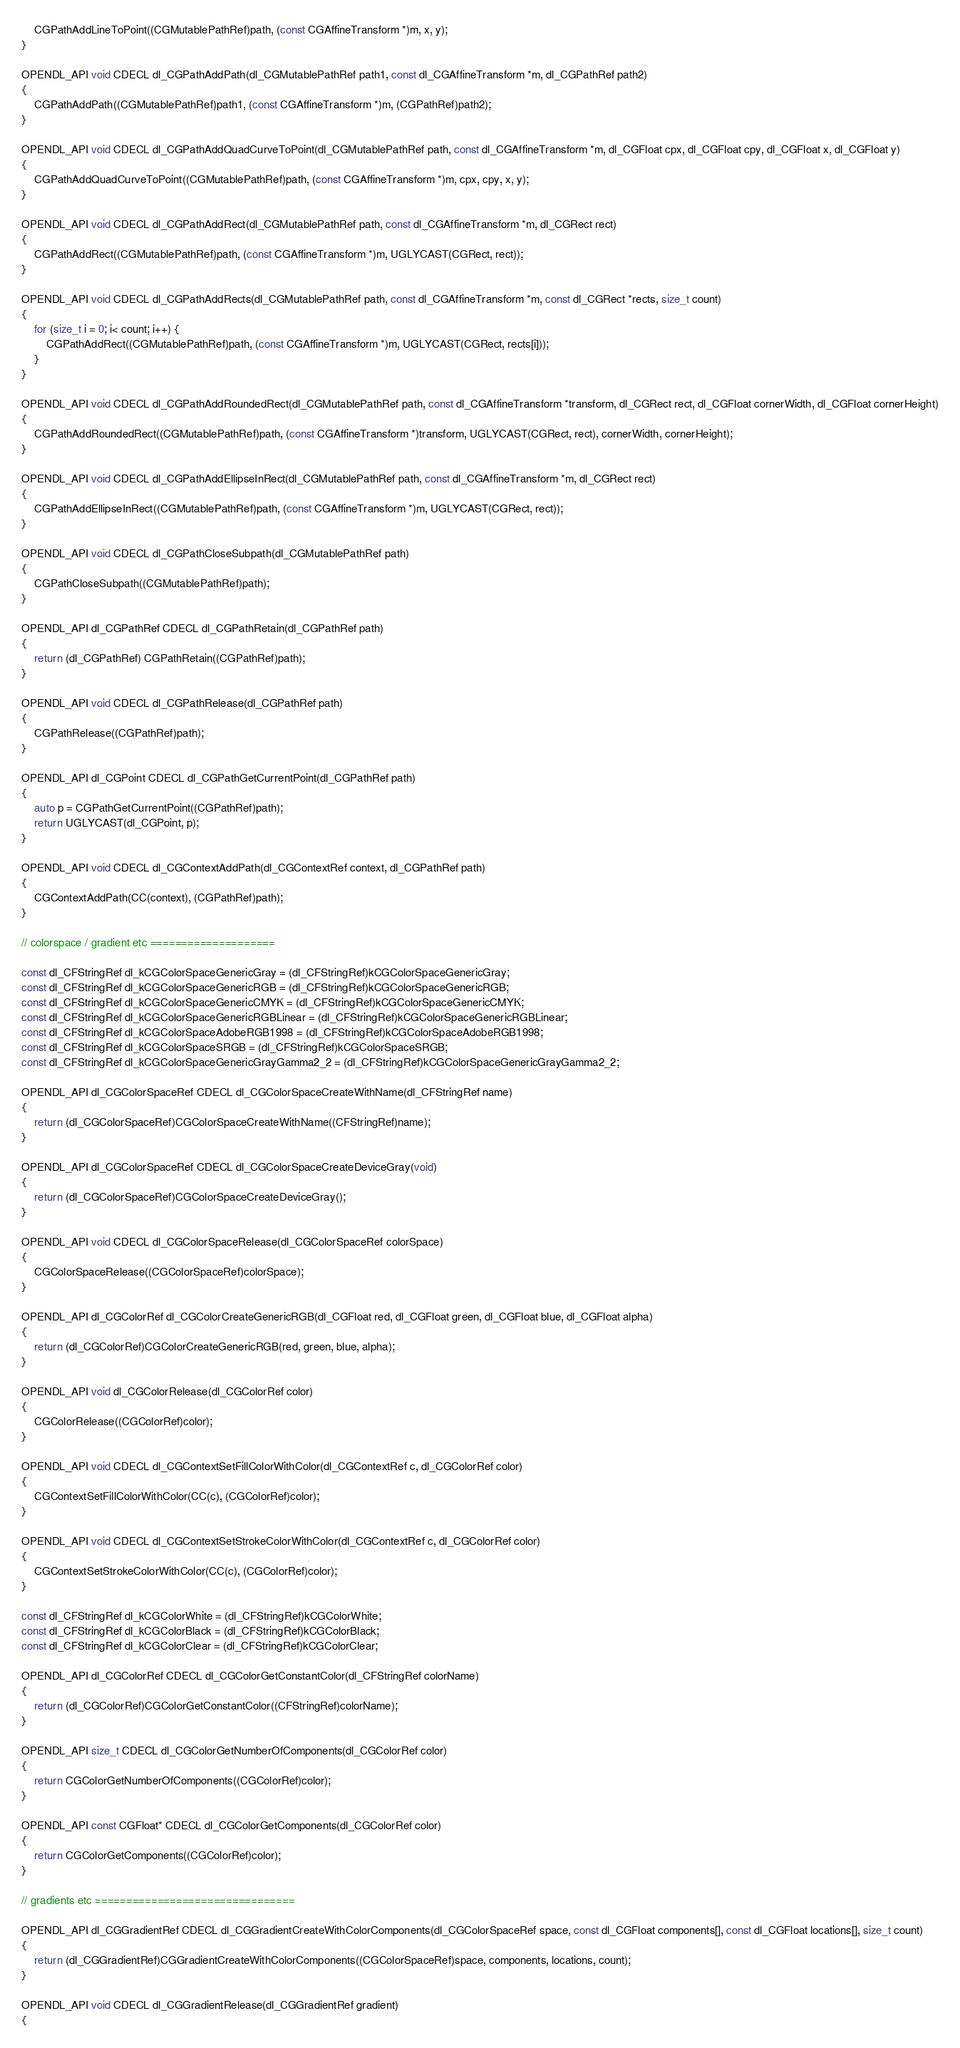Convert code to text. <code><loc_0><loc_0><loc_500><loc_500><_ObjectiveC_>    CGPathAddLineToPoint((CGMutablePathRef)path, (const CGAffineTransform *)m, x, y);
}

OPENDL_API void CDECL dl_CGPathAddPath(dl_CGMutablePathRef path1, const dl_CGAffineTransform *m, dl_CGPathRef path2)
{
    CGPathAddPath((CGMutablePathRef)path1, (const CGAffineTransform *)m, (CGPathRef)path2);
}

OPENDL_API void CDECL dl_CGPathAddQuadCurveToPoint(dl_CGMutablePathRef path, const dl_CGAffineTransform *m, dl_CGFloat cpx, dl_CGFloat cpy, dl_CGFloat x, dl_CGFloat y)
{
    CGPathAddQuadCurveToPoint((CGMutablePathRef)path, (const CGAffineTransform *)m, cpx, cpy, x, y);
}

OPENDL_API void CDECL dl_CGPathAddRect(dl_CGMutablePathRef path, const dl_CGAffineTransform *m, dl_CGRect rect)
{
    CGPathAddRect((CGMutablePathRef)path, (const CGAffineTransform *)m, UGLYCAST(CGRect, rect));
}

OPENDL_API void CDECL dl_CGPathAddRects(dl_CGMutablePathRef path, const dl_CGAffineTransform *m, const dl_CGRect *rects, size_t count)
{
    for (size_t i = 0; i< count; i++) {
        CGPathAddRect((CGMutablePathRef)path, (const CGAffineTransform *)m, UGLYCAST(CGRect, rects[i]));
    }
}

OPENDL_API void CDECL dl_CGPathAddRoundedRect(dl_CGMutablePathRef path, const dl_CGAffineTransform *transform, dl_CGRect rect, dl_CGFloat cornerWidth, dl_CGFloat cornerHeight)
{
    CGPathAddRoundedRect((CGMutablePathRef)path, (const CGAffineTransform *)transform, UGLYCAST(CGRect, rect), cornerWidth, cornerHeight);
}

OPENDL_API void CDECL dl_CGPathAddEllipseInRect(dl_CGMutablePathRef path, const dl_CGAffineTransform *m, dl_CGRect rect)
{
    CGPathAddEllipseInRect((CGMutablePathRef)path, (const CGAffineTransform *)m, UGLYCAST(CGRect, rect));
}

OPENDL_API void CDECL dl_CGPathCloseSubpath(dl_CGMutablePathRef path)
{
    CGPathCloseSubpath((CGMutablePathRef)path);
}

OPENDL_API dl_CGPathRef CDECL dl_CGPathRetain(dl_CGPathRef path)
{
    return (dl_CGPathRef) CGPathRetain((CGPathRef)path);
}

OPENDL_API void CDECL dl_CGPathRelease(dl_CGPathRef path)
{
    CGPathRelease((CGPathRef)path);
}

OPENDL_API dl_CGPoint CDECL dl_CGPathGetCurrentPoint(dl_CGPathRef path)
{
    auto p = CGPathGetCurrentPoint((CGPathRef)path);
    return UGLYCAST(dl_CGPoint, p);
}

OPENDL_API void CDECL dl_CGContextAddPath(dl_CGContextRef context, dl_CGPathRef path)
{
    CGContextAddPath(CC(context), (CGPathRef)path);
}

// colorspace / gradient etc ====================

const dl_CFStringRef dl_kCGColorSpaceGenericGray = (dl_CFStringRef)kCGColorSpaceGenericGray;
const dl_CFStringRef dl_kCGColorSpaceGenericRGB = (dl_CFStringRef)kCGColorSpaceGenericRGB;
const dl_CFStringRef dl_kCGColorSpaceGenericCMYK = (dl_CFStringRef)kCGColorSpaceGenericCMYK;
const dl_CFStringRef dl_kCGColorSpaceGenericRGBLinear = (dl_CFStringRef)kCGColorSpaceGenericRGBLinear;
const dl_CFStringRef dl_kCGColorSpaceAdobeRGB1998 = (dl_CFStringRef)kCGColorSpaceAdobeRGB1998;
const dl_CFStringRef dl_kCGColorSpaceSRGB = (dl_CFStringRef)kCGColorSpaceSRGB;
const dl_CFStringRef dl_kCGColorSpaceGenericGrayGamma2_2 = (dl_CFStringRef)kCGColorSpaceGenericGrayGamma2_2;

OPENDL_API dl_CGColorSpaceRef CDECL dl_CGColorSpaceCreateWithName(dl_CFStringRef name)
{
    return (dl_CGColorSpaceRef)CGColorSpaceCreateWithName((CFStringRef)name);
}

OPENDL_API dl_CGColorSpaceRef CDECL dl_CGColorSpaceCreateDeviceGray(void)
{
    return (dl_CGColorSpaceRef)CGColorSpaceCreateDeviceGray();
}

OPENDL_API void CDECL dl_CGColorSpaceRelease(dl_CGColorSpaceRef colorSpace)
{
    CGColorSpaceRelease((CGColorSpaceRef)colorSpace);
}

OPENDL_API dl_CGColorRef dl_CGColorCreateGenericRGB(dl_CGFloat red, dl_CGFloat green, dl_CGFloat blue, dl_CGFloat alpha)
{
    return (dl_CGColorRef)CGColorCreateGenericRGB(red, green, blue, alpha);
}

OPENDL_API void dl_CGColorRelease(dl_CGColorRef color)
{
    CGColorRelease((CGColorRef)color);
}

OPENDL_API void CDECL dl_CGContextSetFillColorWithColor(dl_CGContextRef c, dl_CGColorRef color)
{
    CGContextSetFillColorWithColor(CC(c), (CGColorRef)color);
}

OPENDL_API void CDECL dl_CGContextSetStrokeColorWithColor(dl_CGContextRef c, dl_CGColorRef color)
{
    CGContextSetStrokeColorWithColor(CC(c), (CGColorRef)color);
}

const dl_CFStringRef dl_kCGColorWhite = (dl_CFStringRef)kCGColorWhite;
const dl_CFStringRef dl_kCGColorBlack = (dl_CFStringRef)kCGColorBlack;
const dl_CFStringRef dl_kCGColorClear = (dl_CFStringRef)kCGColorClear;

OPENDL_API dl_CGColorRef CDECL dl_CGColorGetConstantColor(dl_CFStringRef colorName)
{
    return (dl_CGColorRef)CGColorGetConstantColor((CFStringRef)colorName);
}

OPENDL_API size_t CDECL dl_CGColorGetNumberOfComponents(dl_CGColorRef color)
{
    return CGColorGetNumberOfComponents((CGColorRef)color);
}

OPENDL_API const CGFloat* CDECL dl_CGColorGetComponents(dl_CGColorRef color)
{
    return CGColorGetComponents((CGColorRef)color);
}

// gradients etc ================================

OPENDL_API dl_CGGradientRef CDECL dl_CGGradientCreateWithColorComponents(dl_CGColorSpaceRef space, const dl_CGFloat components[], const dl_CGFloat locations[], size_t count)
{
    return (dl_CGGradientRef)CGGradientCreateWithColorComponents((CGColorSpaceRef)space, components, locations, count);
}

OPENDL_API void CDECL dl_CGGradientRelease(dl_CGGradientRef gradient)
{</code> 